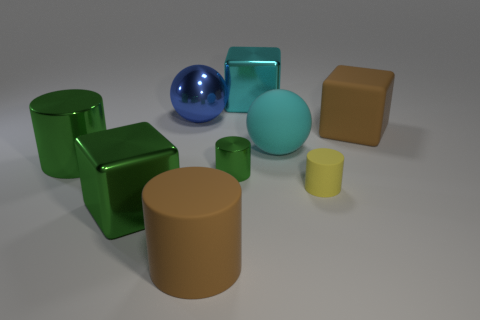There is a brown thing on the left side of the big brown thing right of the large cyan block; what is its shape?
Your answer should be compact. Cylinder. Is there a green metallic block that is behind the green metallic object to the right of the large cylinder that is right of the blue object?
Your answer should be very brief. No. What color is the metal ball that is the same size as the green cube?
Offer a very short reply. Blue. What shape is the object that is both left of the brown cylinder and in front of the small yellow rubber cylinder?
Your answer should be very brief. Cube. What size is the cube that is in front of the large brown thing that is behind the big brown matte cylinder?
Provide a succinct answer. Large. What number of big things have the same color as the big rubber ball?
Ensure brevity in your answer.  1. How many other objects are the same size as the shiny sphere?
Your response must be concise. 6. There is a shiny object that is to the right of the shiny ball and behind the big matte block; what is its size?
Provide a short and direct response. Large. What number of big cyan things have the same shape as the blue metallic object?
Make the answer very short. 1. What is the brown cylinder made of?
Give a very brief answer. Rubber. 